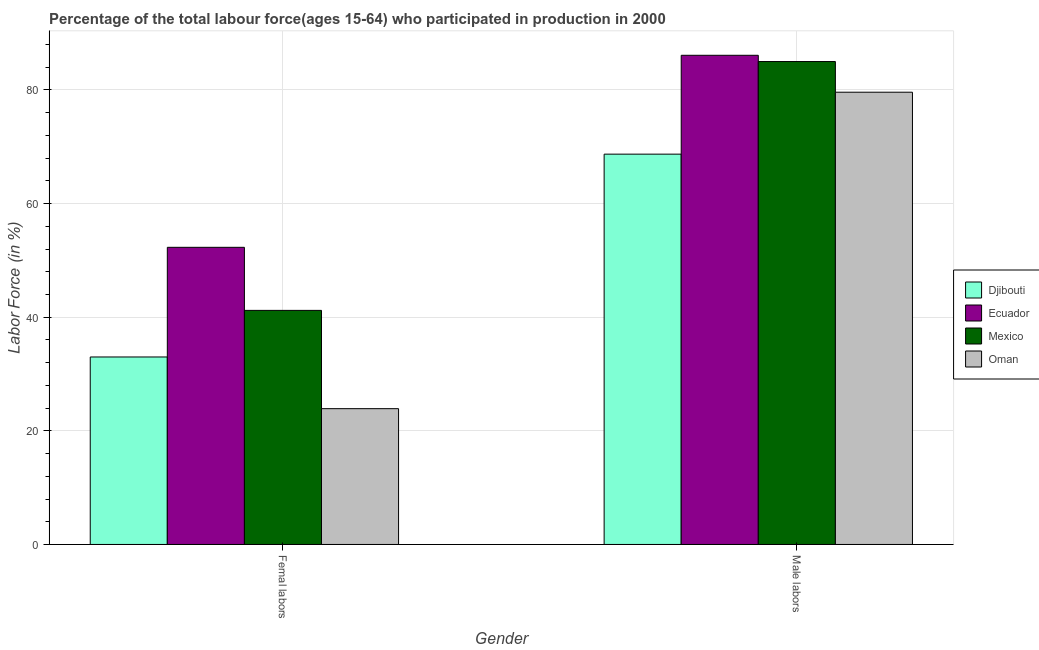How many different coloured bars are there?
Offer a very short reply. 4. How many bars are there on the 2nd tick from the right?
Keep it short and to the point. 4. What is the label of the 1st group of bars from the left?
Your answer should be compact. Femal labors. What is the percentage of female labor force in Djibouti?
Offer a very short reply. 33. Across all countries, what is the maximum percentage of male labour force?
Your response must be concise. 86.1. Across all countries, what is the minimum percentage of female labor force?
Your answer should be compact. 23.9. In which country was the percentage of female labor force maximum?
Your answer should be very brief. Ecuador. In which country was the percentage of female labor force minimum?
Provide a succinct answer. Oman. What is the total percentage of female labor force in the graph?
Your answer should be compact. 150.4. What is the difference between the percentage of male labour force in Ecuador and that in Djibouti?
Give a very brief answer. 17.4. What is the difference between the percentage of male labour force in Oman and the percentage of female labor force in Mexico?
Make the answer very short. 38.4. What is the average percentage of female labor force per country?
Give a very brief answer. 37.6. What is the difference between the percentage of male labour force and percentage of female labor force in Djibouti?
Your answer should be compact. 35.7. What is the ratio of the percentage of male labour force in Oman to that in Ecuador?
Your answer should be very brief. 0.92. Is the percentage of female labor force in Mexico less than that in Oman?
Your response must be concise. No. What does the 2nd bar from the right in Femal labors represents?
Ensure brevity in your answer.  Mexico. How many bars are there?
Your answer should be very brief. 8. How many countries are there in the graph?
Ensure brevity in your answer.  4. Does the graph contain grids?
Give a very brief answer. Yes. How many legend labels are there?
Give a very brief answer. 4. What is the title of the graph?
Provide a short and direct response. Percentage of the total labour force(ages 15-64) who participated in production in 2000. Does "Cuba" appear as one of the legend labels in the graph?
Your answer should be very brief. No. What is the Labor Force (in %) of Djibouti in Femal labors?
Keep it short and to the point. 33. What is the Labor Force (in %) in Ecuador in Femal labors?
Keep it short and to the point. 52.3. What is the Labor Force (in %) in Mexico in Femal labors?
Ensure brevity in your answer.  41.2. What is the Labor Force (in %) in Oman in Femal labors?
Provide a short and direct response. 23.9. What is the Labor Force (in %) in Djibouti in Male labors?
Provide a short and direct response. 68.7. What is the Labor Force (in %) in Ecuador in Male labors?
Offer a very short reply. 86.1. What is the Labor Force (in %) of Mexico in Male labors?
Offer a terse response. 85. What is the Labor Force (in %) in Oman in Male labors?
Offer a very short reply. 79.6. Across all Gender, what is the maximum Labor Force (in %) of Djibouti?
Keep it short and to the point. 68.7. Across all Gender, what is the maximum Labor Force (in %) in Ecuador?
Ensure brevity in your answer.  86.1. Across all Gender, what is the maximum Labor Force (in %) in Mexico?
Your answer should be compact. 85. Across all Gender, what is the maximum Labor Force (in %) of Oman?
Offer a very short reply. 79.6. Across all Gender, what is the minimum Labor Force (in %) of Ecuador?
Give a very brief answer. 52.3. Across all Gender, what is the minimum Labor Force (in %) in Mexico?
Your answer should be compact. 41.2. Across all Gender, what is the minimum Labor Force (in %) in Oman?
Provide a succinct answer. 23.9. What is the total Labor Force (in %) of Djibouti in the graph?
Provide a succinct answer. 101.7. What is the total Labor Force (in %) of Ecuador in the graph?
Ensure brevity in your answer.  138.4. What is the total Labor Force (in %) of Mexico in the graph?
Your answer should be very brief. 126.2. What is the total Labor Force (in %) of Oman in the graph?
Your answer should be compact. 103.5. What is the difference between the Labor Force (in %) of Djibouti in Femal labors and that in Male labors?
Provide a short and direct response. -35.7. What is the difference between the Labor Force (in %) in Ecuador in Femal labors and that in Male labors?
Provide a short and direct response. -33.8. What is the difference between the Labor Force (in %) in Mexico in Femal labors and that in Male labors?
Provide a succinct answer. -43.8. What is the difference between the Labor Force (in %) of Oman in Femal labors and that in Male labors?
Provide a short and direct response. -55.7. What is the difference between the Labor Force (in %) in Djibouti in Femal labors and the Labor Force (in %) in Ecuador in Male labors?
Offer a very short reply. -53.1. What is the difference between the Labor Force (in %) in Djibouti in Femal labors and the Labor Force (in %) in Mexico in Male labors?
Keep it short and to the point. -52. What is the difference between the Labor Force (in %) in Djibouti in Femal labors and the Labor Force (in %) in Oman in Male labors?
Your response must be concise. -46.6. What is the difference between the Labor Force (in %) of Ecuador in Femal labors and the Labor Force (in %) of Mexico in Male labors?
Keep it short and to the point. -32.7. What is the difference between the Labor Force (in %) of Ecuador in Femal labors and the Labor Force (in %) of Oman in Male labors?
Your answer should be very brief. -27.3. What is the difference between the Labor Force (in %) of Mexico in Femal labors and the Labor Force (in %) of Oman in Male labors?
Your answer should be compact. -38.4. What is the average Labor Force (in %) in Djibouti per Gender?
Give a very brief answer. 50.85. What is the average Labor Force (in %) of Ecuador per Gender?
Offer a terse response. 69.2. What is the average Labor Force (in %) of Mexico per Gender?
Offer a very short reply. 63.1. What is the average Labor Force (in %) of Oman per Gender?
Provide a succinct answer. 51.75. What is the difference between the Labor Force (in %) of Djibouti and Labor Force (in %) of Ecuador in Femal labors?
Offer a very short reply. -19.3. What is the difference between the Labor Force (in %) of Djibouti and Labor Force (in %) of Oman in Femal labors?
Make the answer very short. 9.1. What is the difference between the Labor Force (in %) in Ecuador and Labor Force (in %) in Mexico in Femal labors?
Your response must be concise. 11.1. What is the difference between the Labor Force (in %) in Ecuador and Labor Force (in %) in Oman in Femal labors?
Give a very brief answer. 28.4. What is the difference between the Labor Force (in %) in Mexico and Labor Force (in %) in Oman in Femal labors?
Offer a very short reply. 17.3. What is the difference between the Labor Force (in %) in Djibouti and Labor Force (in %) in Ecuador in Male labors?
Your response must be concise. -17.4. What is the difference between the Labor Force (in %) in Djibouti and Labor Force (in %) in Mexico in Male labors?
Your answer should be very brief. -16.3. What is the difference between the Labor Force (in %) of Djibouti and Labor Force (in %) of Oman in Male labors?
Offer a very short reply. -10.9. What is the difference between the Labor Force (in %) in Ecuador and Labor Force (in %) in Mexico in Male labors?
Provide a short and direct response. 1.1. What is the difference between the Labor Force (in %) in Ecuador and Labor Force (in %) in Oman in Male labors?
Your response must be concise. 6.5. What is the difference between the Labor Force (in %) of Mexico and Labor Force (in %) of Oman in Male labors?
Offer a terse response. 5.4. What is the ratio of the Labor Force (in %) in Djibouti in Femal labors to that in Male labors?
Provide a succinct answer. 0.48. What is the ratio of the Labor Force (in %) of Ecuador in Femal labors to that in Male labors?
Offer a very short reply. 0.61. What is the ratio of the Labor Force (in %) in Mexico in Femal labors to that in Male labors?
Your response must be concise. 0.48. What is the ratio of the Labor Force (in %) in Oman in Femal labors to that in Male labors?
Your response must be concise. 0.3. What is the difference between the highest and the second highest Labor Force (in %) in Djibouti?
Give a very brief answer. 35.7. What is the difference between the highest and the second highest Labor Force (in %) in Ecuador?
Give a very brief answer. 33.8. What is the difference between the highest and the second highest Labor Force (in %) of Mexico?
Your answer should be compact. 43.8. What is the difference between the highest and the second highest Labor Force (in %) of Oman?
Give a very brief answer. 55.7. What is the difference between the highest and the lowest Labor Force (in %) in Djibouti?
Offer a very short reply. 35.7. What is the difference between the highest and the lowest Labor Force (in %) of Ecuador?
Ensure brevity in your answer.  33.8. What is the difference between the highest and the lowest Labor Force (in %) of Mexico?
Your answer should be compact. 43.8. What is the difference between the highest and the lowest Labor Force (in %) of Oman?
Give a very brief answer. 55.7. 